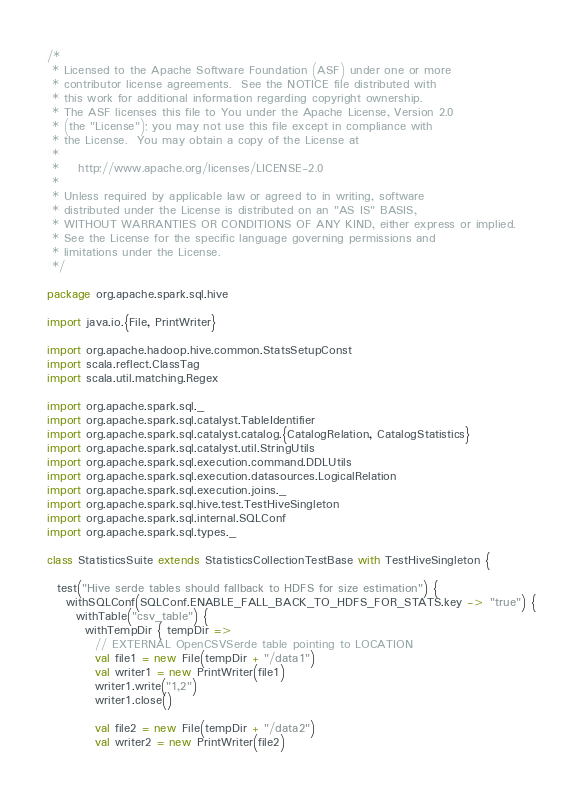Convert code to text. <code><loc_0><loc_0><loc_500><loc_500><_Scala_>/*
 * Licensed to the Apache Software Foundation (ASF) under one or more
 * contributor license agreements.  See the NOTICE file distributed with
 * this work for additional information regarding copyright ownership.
 * The ASF licenses this file to You under the Apache License, Version 2.0
 * (the "License"); you may not use this file except in compliance with
 * the License.  You may obtain a copy of the License at
 *
 *    http://www.apache.org/licenses/LICENSE-2.0
 *
 * Unless required by applicable law or agreed to in writing, software
 * distributed under the License is distributed on an "AS IS" BASIS,
 * WITHOUT WARRANTIES OR CONDITIONS OF ANY KIND, either express or implied.
 * See the License for the specific language governing permissions and
 * limitations under the License.
 */

package org.apache.spark.sql.hive

import java.io.{File, PrintWriter}

import org.apache.hadoop.hive.common.StatsSetupConst
import scala.reflect.ClassTag
import scala.util.matching.Regex

import org.apache.spark.sql._
import org.apache.spark.sql.catalyst.TableIdentifier
import org.apache.spark.sql.catalyst.catalog.{CatalogRelation, CatalogStatistics}
import org.apache.spark.sql.catalyst.util.StringUtils
import org.apache.spark.sql.execution.command.DDLUtils
import org.apache.spark.sql.execution.datasources.LogicalRelation
import org.apache.spark.sql.execution.joins._
import org.apache.spark.sql.hive.test.TestHiveSingleton
import org.apache.spark.sql.internal.SQLConf
import org.apache.spark.sql.types._

class StatisticsSuite extends StatisticsCollectionTestBase with TestHiveSingleton {

  test("Hive serde tables should fallback to HDFS for size estimation") {
    withSQLConf(SQLConf.ENABLE_FALL_BACK_TO_HDFS_FOR_STATS.key -> "true") {
      withTable("csv_table") {
        withTempDir { tempDir =>
          // EXTERNAL OpenCSVSerde table pointing to LOCATION
          val file1 = new File(tempDir + "/data1")
          val writer1 = new PrintWriter(file1)
          writer1.write("1,2")
          writer1.close()

          val file2 = new File(tempDir + "/data2")
          val writer2 = new PrintWriter(file2)</code> 